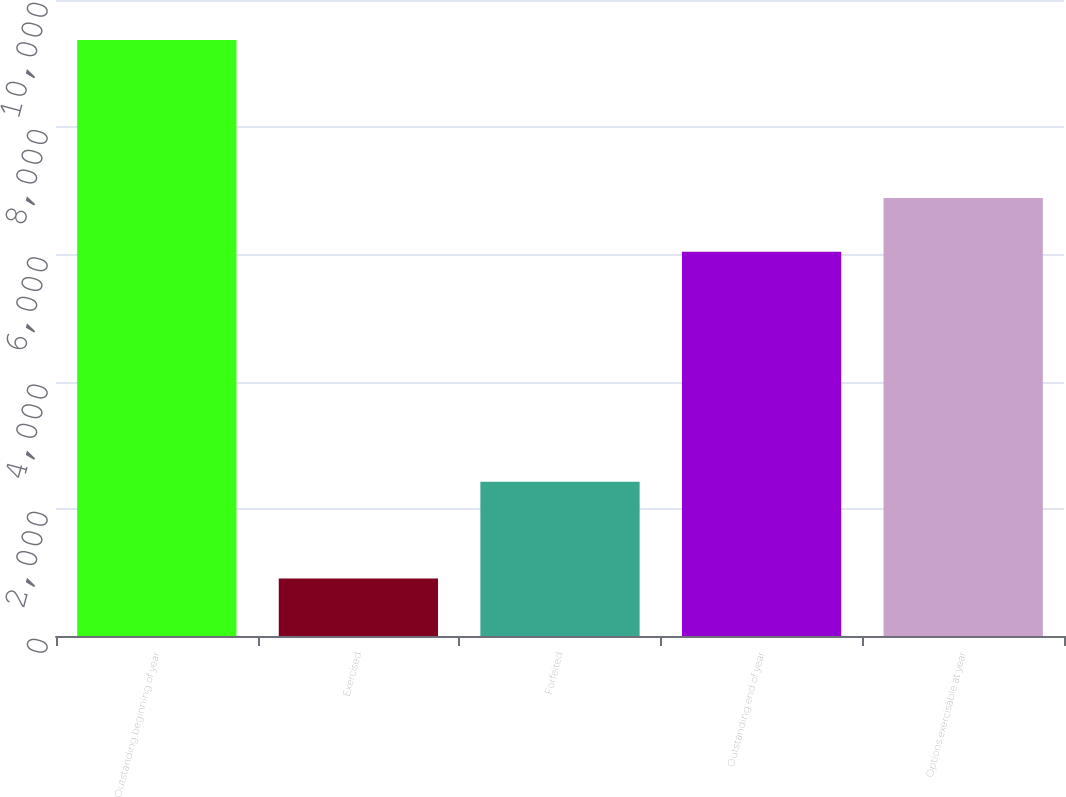<chart> <loc_0><loc_0><loc_500><loc_500><bar_chart><fcel>Outstanding beginning of year<fcel>Exercised<fcel>Forfeited<fcel>Outstanding end of year<fcel>Options exercisable at year<nl><fcel>9370<fcel>904<fcel>2426<fcel>6040<fcel>6886.6<nl></chart> 